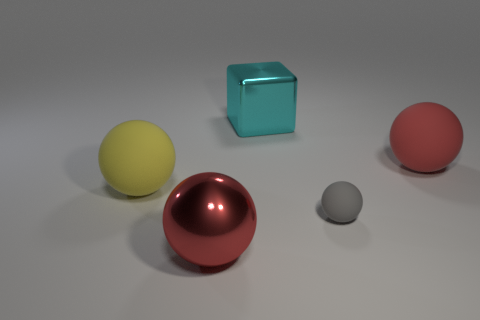What is the color of the big rubber thing to the right of the red thing that is to the left of the cyan shiny thing?
Provide a succinct answer. Red. What number of tiny objects are either purple metal cylinders or red rubber things?
Your answer should be very brief. 0. The big sphere that is both on the left side of the large red matte thing and behind the shiny ball is what color?
Your answer should be compact. Yellow. Is the material of the big cyan cube the same as the gray thing?
Offer a very short reply. No. What shape is the gray rubber thing?
Offer a very short reply. Sphere. There is a small matte object that is left of the big red thing that is to the right of the cyan thing; what number of large metal things are in front of it?
Make the answer very short. 1. The other tiny object that is the same shape as the yellow thing is what color?
Provide a short and direct response. Gray. What shape is the cyan metallic thing behind the thing that is in front of the tiny object that is in front of the cyan cube?
Offer a very short reply. Cube. There is a thing that is both in front of the yellow rubber ball and to the right of the large metal sphere; what size is it?
Provide a short and direct response. Small. Is the number of big yellow rubber balls less than the number of brown matte balls?
Ensure brevity in your answer.  No. 